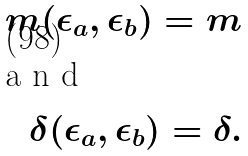<formula> <loc_0><loc_0><loc_500><loc_500>m ( \epsilon _ { a } , \epsilon _ { b } ) = m \\ \intertext { a n d } \delta ( \epsilon _ { a } , \epsilon _ { b } ) = \delta .</formula> 